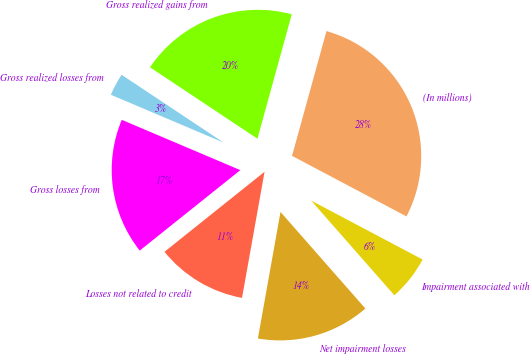Convert chart to OTSL. <chart><loc_0><loc_0><loc_500><loc_500><pie_chart><fcel>(In millions)<fcel>Gross realized gains from<fcel>Gross realized losses from<fcel>Gross losses from<fcel>Losses not related to credit<fcel>Net impairment losses<fcel>Impairment associated with<nl><fcel>28.46%<fcel>19.95%<fcel>2.95%<fcel>17.12%<fcel>11.45%<fcel>14.29%<fcel>5.78%<nl></chart> 